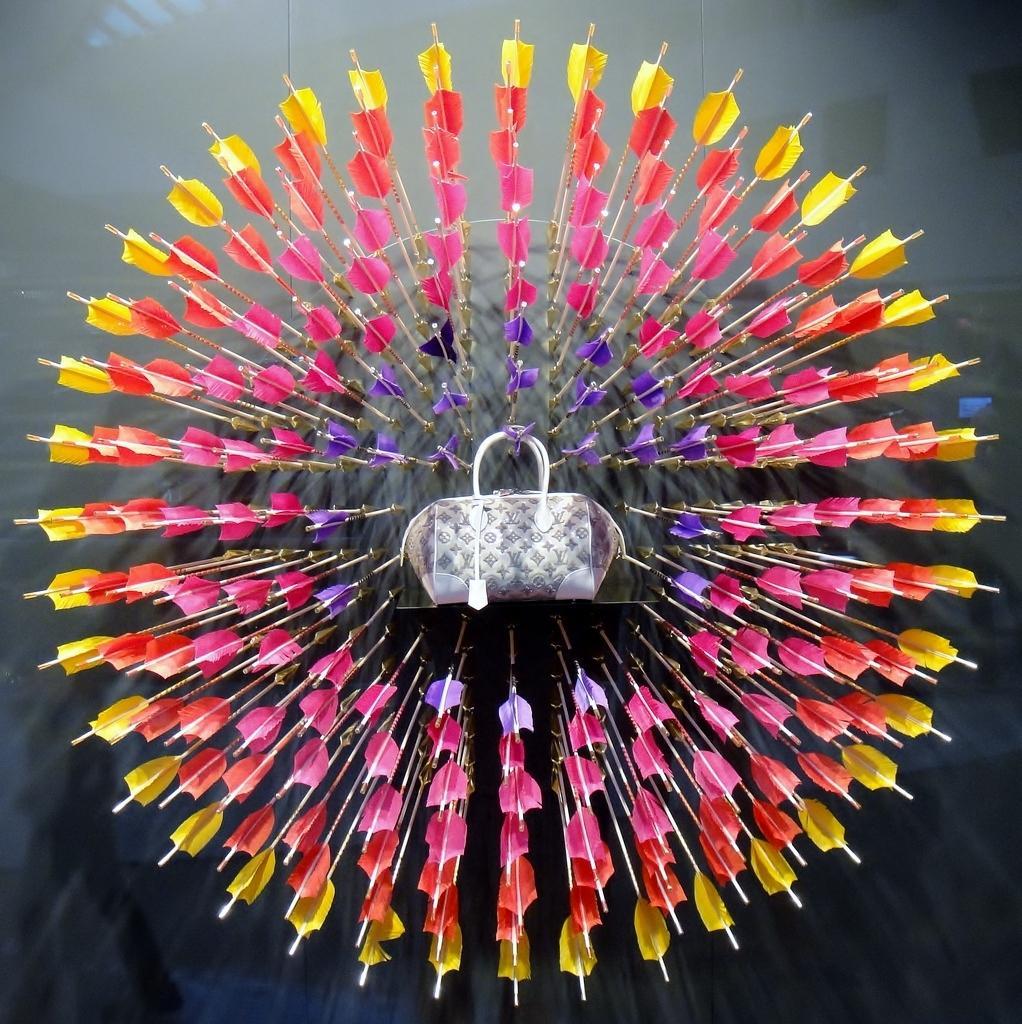How would you summarize this image in a sentence or two? In a picture we can see a arrows with design and we can also see a handbag which is white in colour with tag. 